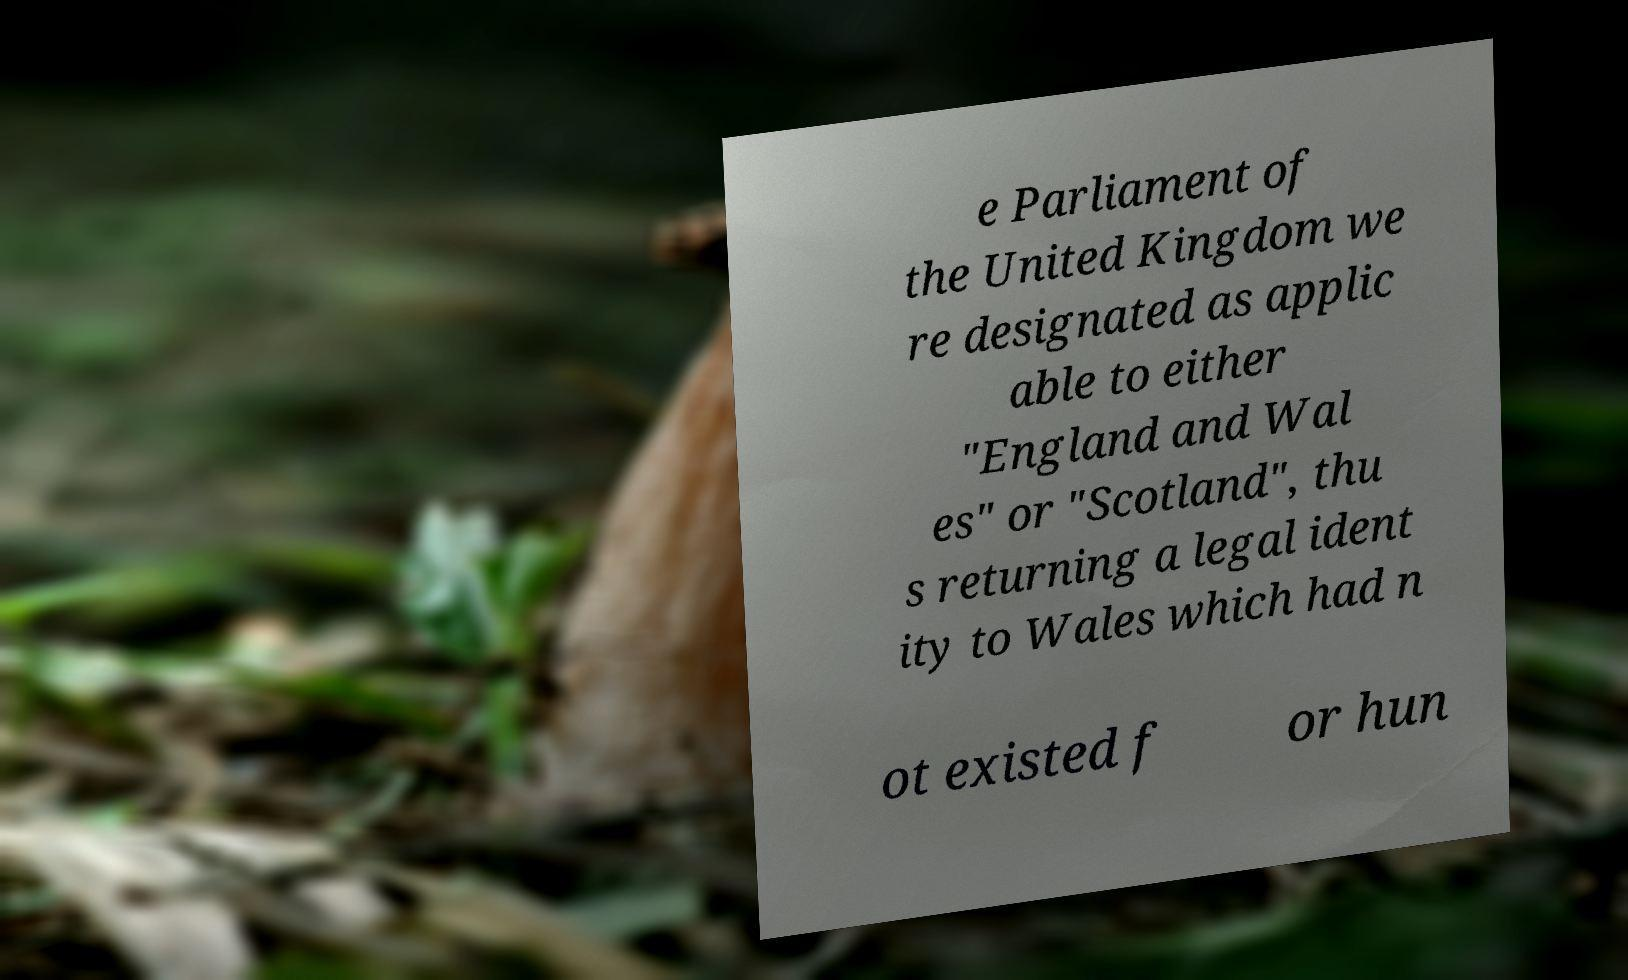I need the written content from this picture converted into text. Can you do that? e Parliament of the United Kingdom we re designated as applic able to either "England and Wal es" or "Scotland", thu s returning a legal ident ity to Wales which had n ot existed f or hun 